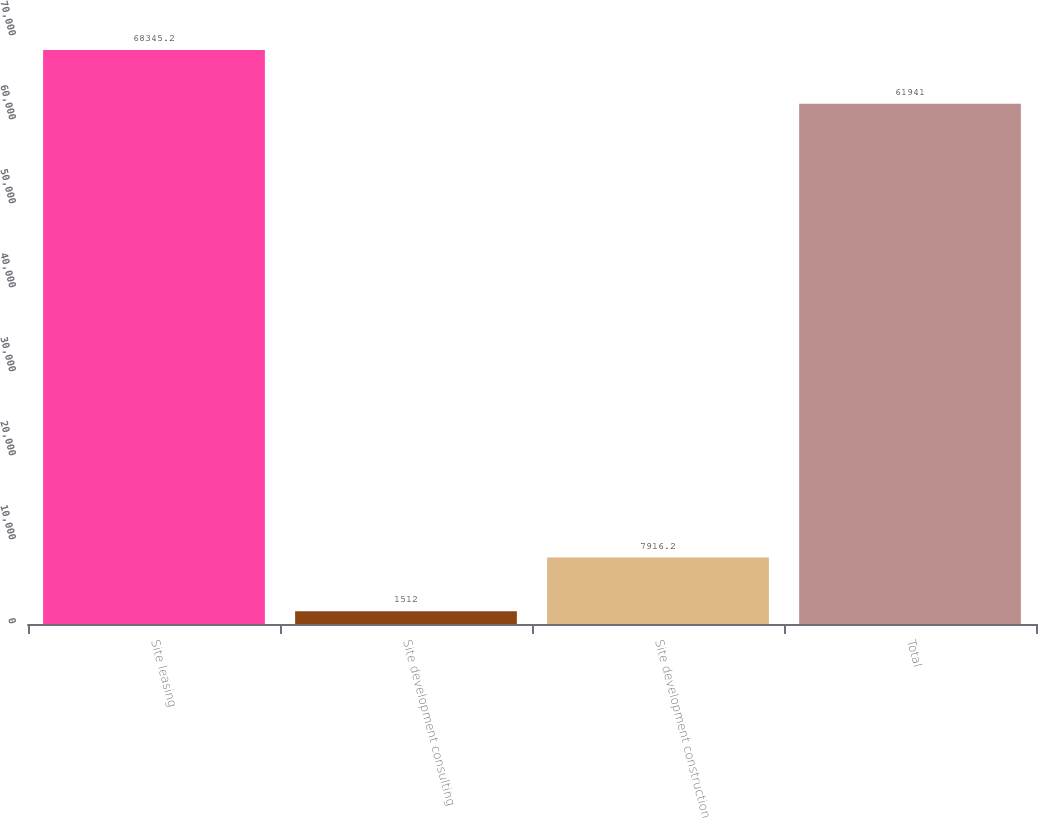Convert chart to OTSL. <chart><loc_0><loc_0><loc_500><loc_500><bar_chart><fcel>Site leasing<fcel>Site development consulting<fcel>Site development construction<fcel>Total<nl><fcel>68345.2<fcel>1512<fcel>7916.2<fcel>61941<nl></chart> 